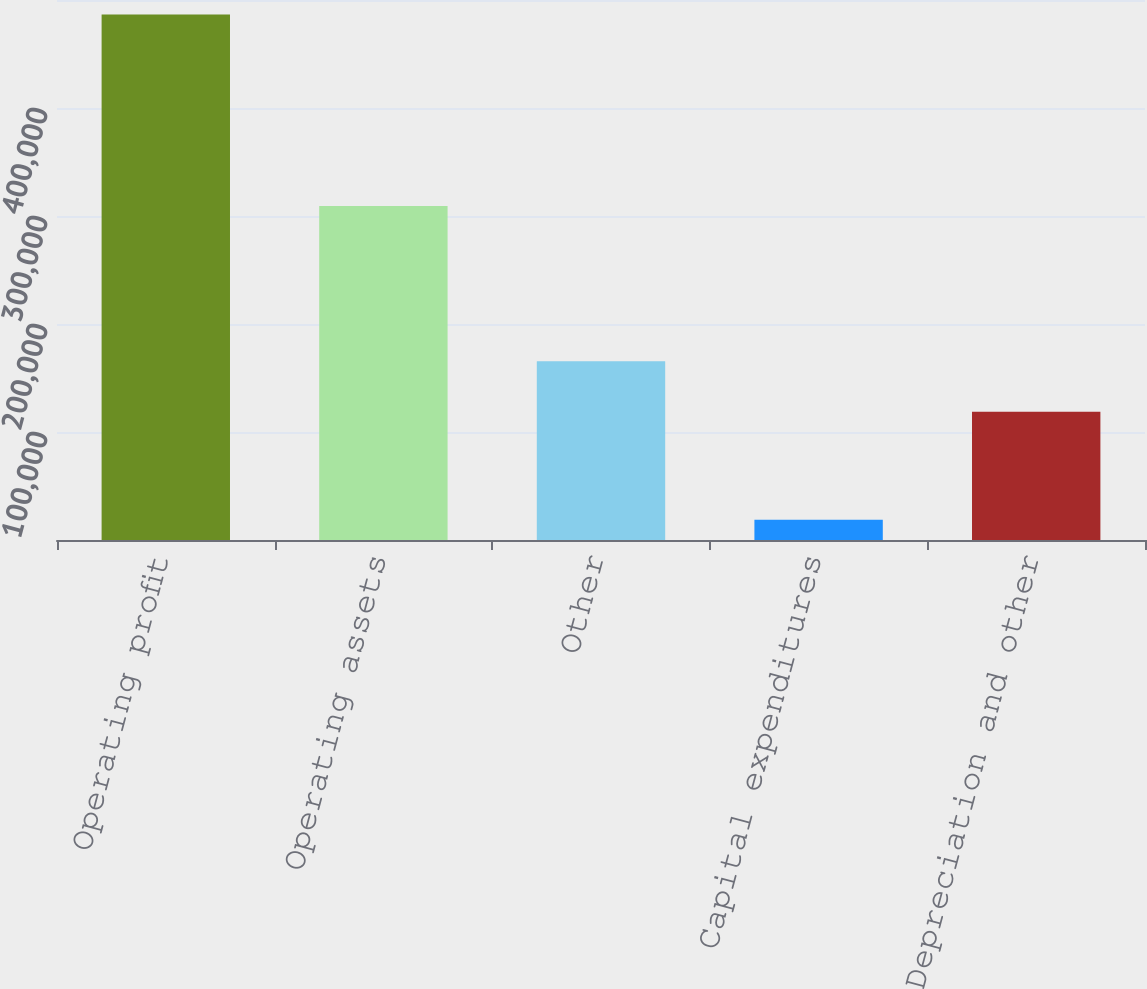Convert chart to OTSL. <chart><loc_0><loc_0><loc_500><loc_500><bar_chart><fcel>Operating profit<fcel>Operating assets<fcel>Other<fcel>Capital expenditures<fcel>Depreciation and other<nl><fcel>486575<fcel>309235<fcel>165421<fcel>18791<fcel>118643<nl></chart> 